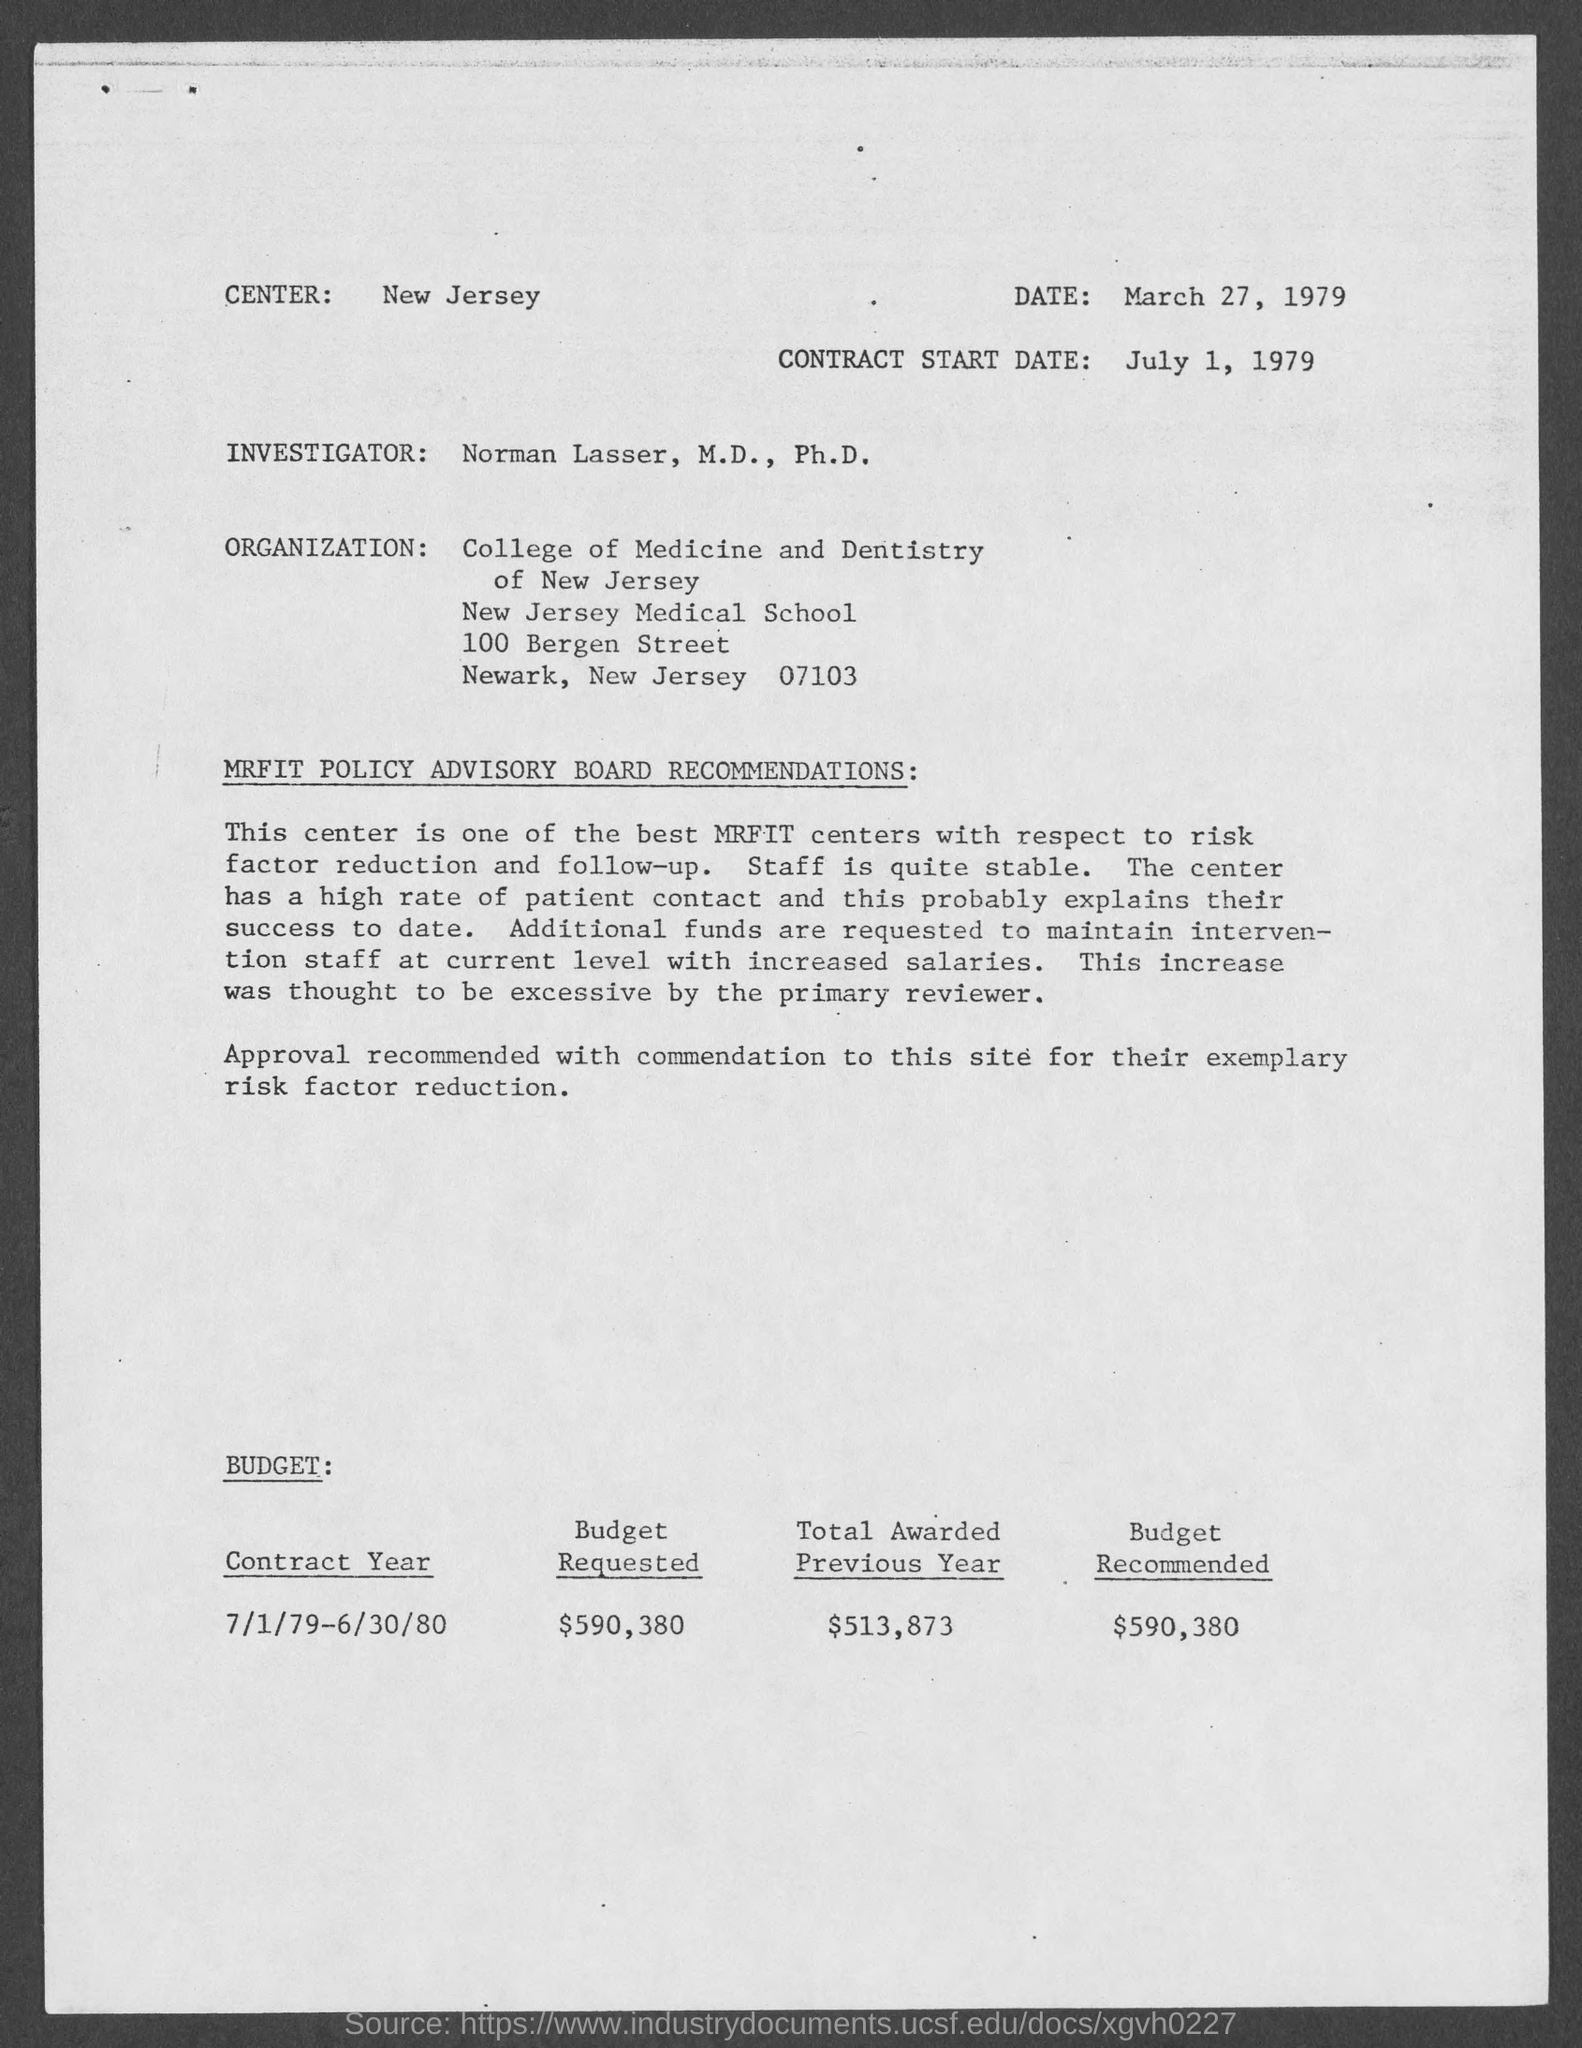What is the contract start date mentioned in the document?
Provide a short and direct response. July 1, 1979. Which is the center given in the document?
Keep it short and to the point. New Jersey. Who is the Investigator as per the document?
Your response must be concise. Norman Lasser, M.D., Ph.D. What is the Budget requested for the contract year 7/1/79-6/30/80?
Keep it short and to the point. $590,380. 